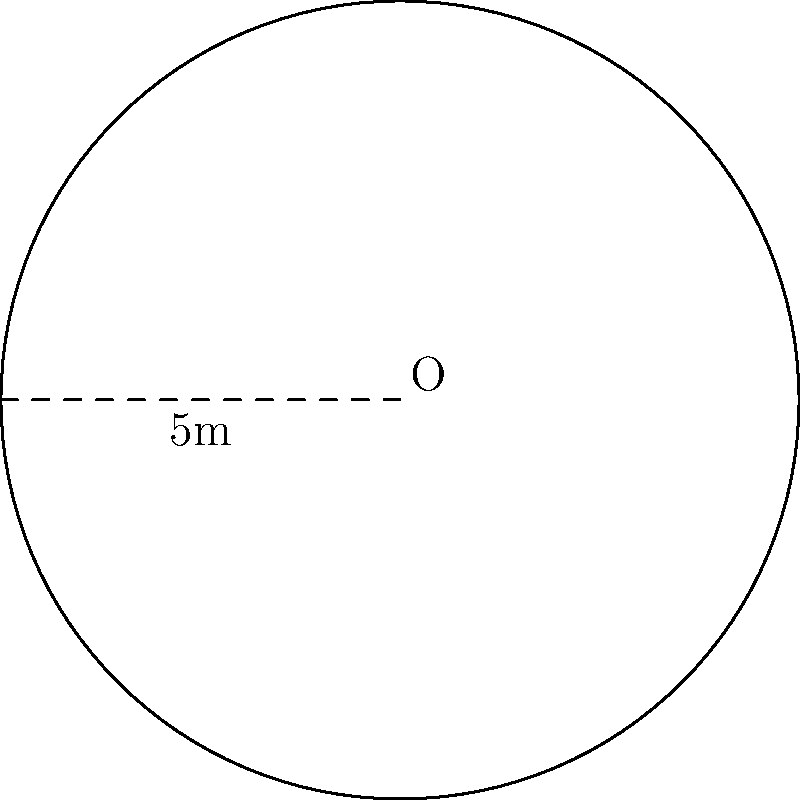At a popular co-working space, the Wi-Fi router provides circular coverage. If the radius of the coverage area is 5 meters, what is the total area that can receive a Wi-Fi signal? Round your answer to the nearest square meter. To solve this problem, we'll follow these steps:

1. Identify the formula for the area of a circle:
   The area of a circle is given by the formula $A = \pi r^2$, where $A$ is the area and $r$ is the radius.

2. Substitute the given radius into the formula:
   We know that the radius is 5 meters, so we have:
   $A = \pi (5)^2$

3. Calculate the result:
   $A = \pi (25)$
   $A = 25\pi \approx 78.54$ square meters

4. Round to the nearest square meter:
   78.54 rounds to 79 square meters.

Therefore, the total area that can receive a Wi-Fi signal is approximately 79 square meters.
Answer: 79 m² 